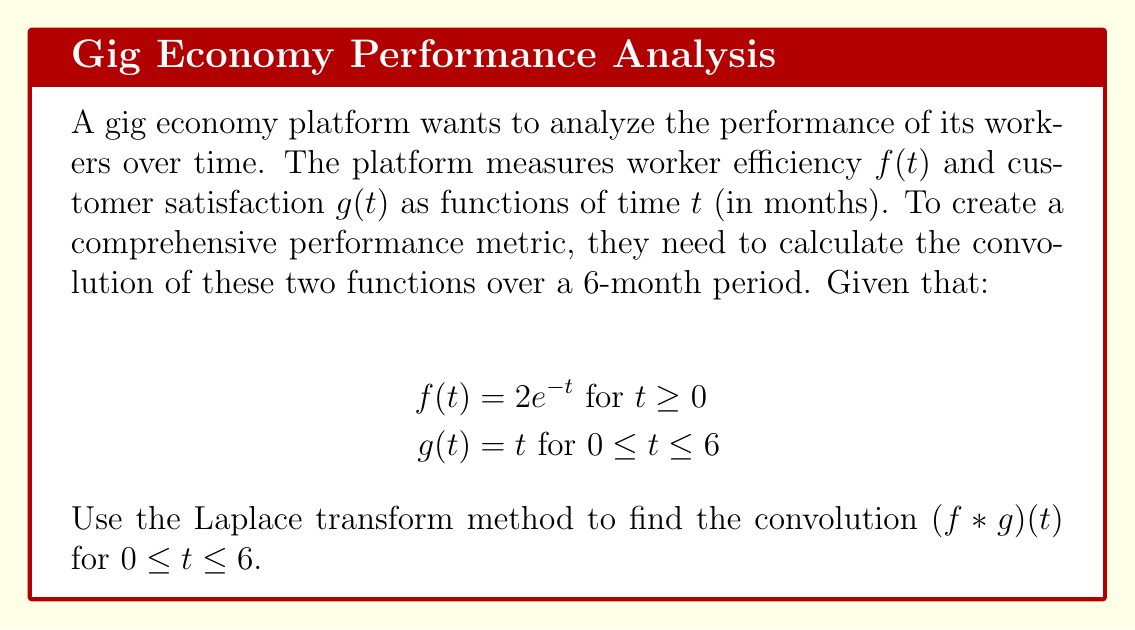Can you solve this math problem? To solve this convolution problem using Laplace transforms, we'll follow these steps:

1) First, let's recall the convolution theorem:
   $\mathcal{L}\{f * g\} = \mathcal{L}\{f\} \cdot \mathcal{L}\{g\}$

2) We need to find the Laplace transforms of $f(t)$ and $g(t)$:

   For $f(t) = 2e^{-t}$:
   $$\mathcal{L}\{f(t)\} = \mathcal{L}\{2e^{-t}\} = \frac{2}{s+1}$$

   For $g(t) = t$ (considering the limit of 6 months):
   $$\mathcal{L}\{g(t)\} = \mathcal{L}\{t\} - e^{-6s}\mathcal{L}\{t\} = \frac{1}{s^2} - e^{-6s}\frac{1}{s^2}$$

3) Now, we multiply these Laplace transforms:
   $$\mathcal{L}\{f * g\} = \frac{2}{s+1} \cdot (\frac{1}{s^2} - e^{-6s}\frac{1}{s^2})$$

4) Simplify:
   $$\mathcal{L}\{f * g\} = \frac{2}{s^2(s+1)} - \frac{2e^{-6s}}{s^2(s+1)}$$

5) To find the inverse Laplace transform, we can use partial fraction decomposition:
   $$\frac{2}{s^2(s+1)} = \frac{2}{s} - \frac{2}{s^2} + \frac{2}{s+1}$$

6) Taking the inverse Laplace transform:
   $$\mathcal{L}^{-1}\{\frac{2}{s^2(s+1)}\} = 2 - 2t + 2e^{-t}$$

7) For the term with $e^{-6s}$, we use the time-shift property:
   $$\mathcal{L}^{-1}\{\frac{2e^{-6s}}{s^2(s+1)}\} = u(t-6)[2 - 2(t-6) + 2e^{-(t-6)}]$$
   where $u(t-6)$ is the unit step function.

8) Combining these results:
   $$(f * g)(t) = 2 - 2t + 2e^{-t} - u(t-6)[2 - 2(t-6) + 2e^{-(t-6)}]$$

9) For $0 \leq t \leq 6$, the unit step function term is zero, so our final result is:
   $$(f * g)(t) = 2 - 2t + 2e^{-t}, \quad 0 \leq t \leq 6$$
Answer: $(f * g)(t) = 2 - 2t + 2e^{-t}$ for $0 \leq t \leq 6$ 